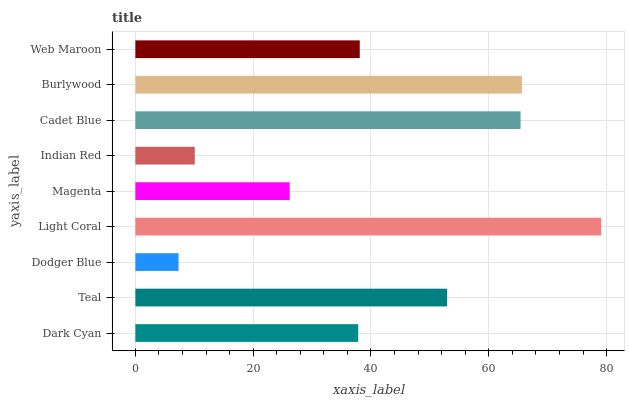Is Dodger Blue the minimum?
Answer yes or no. Yes. Is Light Coral the maximum?
Answer yes or no. Yes. Is Teal the minimum?
Answer yes or no. No. Is Teal the maximum?
Answer yes or no. No. Is Teal greater than Dark Cyan?
Answer yes or no. Yes. Is Dark Cyan less than Teal?
Answer yes or no. Yes. Is Dark Cyan greater than Teal?
Answer yes or no. No. Is Teal less than Dark Cyan?
Answer yes or no. No. Is Web Maroon the high median?
Answer yes or no. Yes. Is Web Maroon the low median?
Answer yes or no. Yes. Is Indian Red the high median?
Answer yes or no. No. Is Dodger Blue the low median?
Answer yes or no. No. 